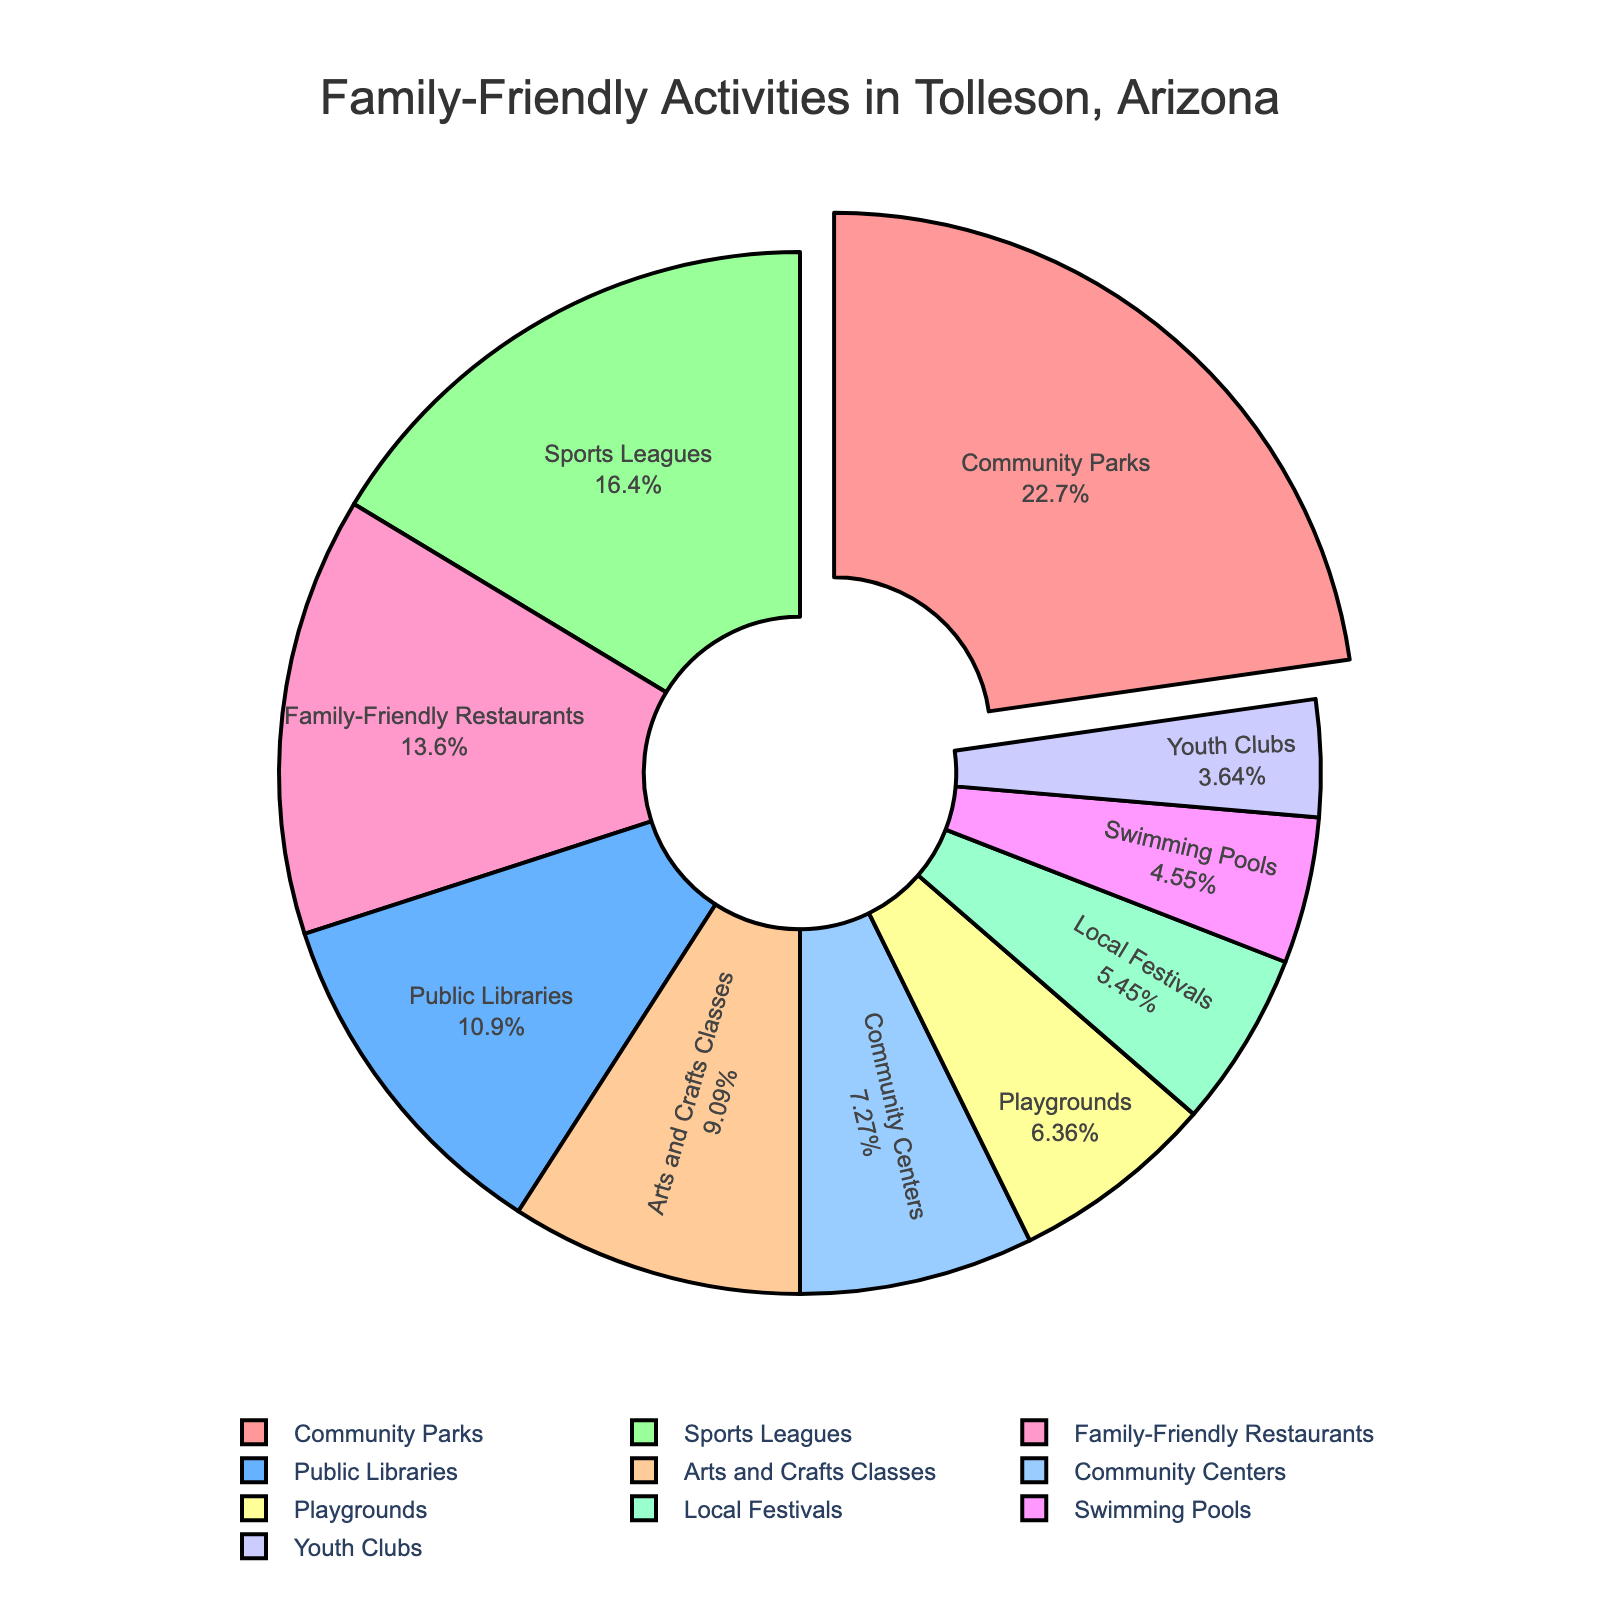Which activity type takes up the largest percentage in the pie chart? The largest percentage segment is visually more prominent and pulled out slightly from the pie. This segment is also listed with the highest percentage.
Answer: Community Parks Which activity type is represented by the smallest slice in the pie chart? The smallest percentage slice will be the least visually prominent and smallest in the chart.
Answer: Youth Clubs How do the percentages of Sports Leagues and Family-Friendly Restaurants compare? Comparing the two segments visually and checking their listed percentages in the pie chart.
Answer: Sports Leagues are larger What is the combined percentage of Community Parks and Public Libraries? Add the percentages of Community Parks (25%) and Public Libraries (12%).
Answer: 37% Are the percentages of Playgrounds and Swimming Pools equal? Visually compare the size of the slices representing Playgrounds and Swimming Pools and see if the numbers match.
Answer: No What is the difference in percentage between Sports Leagues and Arts and Crafts Classes? Subtract the percentage of Arts and Crafts Classes (10%) from the percentage of Sports Leagues (18%).
Answer: 8% Which activity type shares the same color as the Community Centers segment? Identify the color of the Community Centers segment and find the segment with the same color.
Answer: Local Festivals Which two segments together encompass roughly the same percentage as Community Parks? Find two segments whose combined percentage values (e.g., Public Libraries and Sports Leagues) approximately equal to 25%.
Answer: Family-Friendly Restaurants and Sports Leagues Is there any activity type with a percentage less than 5%? Identify all the segments and check their percentages. Look for any value below 5%.
Answer: No What is the average percentage of Arts and Crafts Classes and Youth Clubs? Add the percentages of Arts and Crafts Classes (10%) and Youth Clubs (4%) and divide by 2.
Answer: 7% 